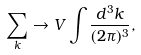Convert formula to latex. <formula><loc_0><loc_0><loc_500><loc_500>\sum _ { k } \rightarrow V \int \frac { d ^ { 3 } k } { ( 2 \pi ) ^ { 3 } } ,</formula> 